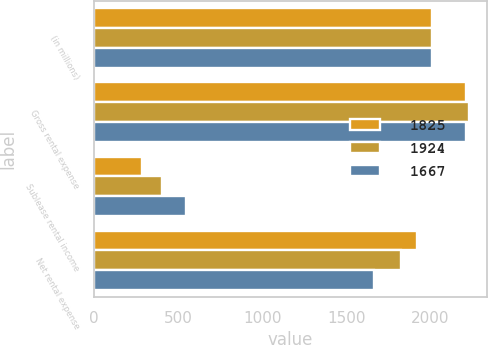<chart> <loc_0><loc_0><loc_500><loc_500><stacked_bar_chart><ecel><fcel>(in millions)<fcel>Gross rental expense<fcel>Sublease rental income<fcel>Net rental expense<nl><fcel>1825<fcel>2012<fcel>2212<fcel>288<fcel>1924<nl><fcel>1924<fcel>2011<fcel>2228<fcel>403<fcel>1825<nl><fcel>1667<fcel>2010<fcel>2212<fcel>545<fcel>1667<nl></chart> 